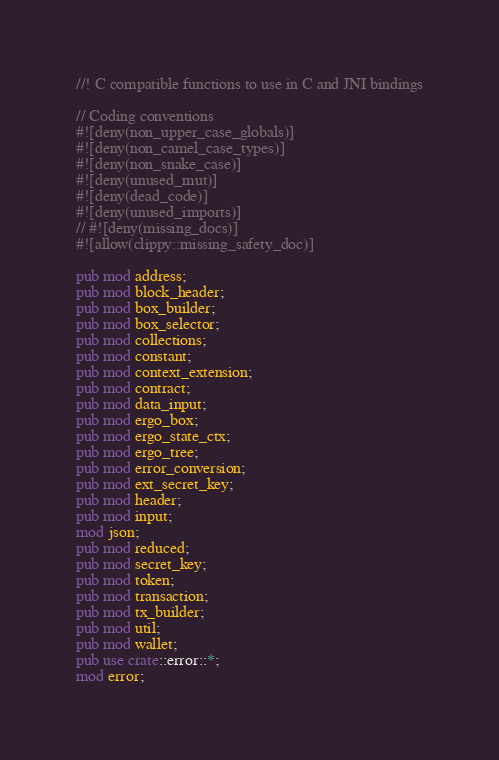Convert code to text. <code><loc_0><loc_0><loc_500><loc_500><_Rust_>//! C compatible functions to use in C and JNI bindings

// Coding conventions
#![deny(non_upper_case_globals)]
#![deny(non_camel_case_types)]
#![deny(non_snake_case)]
#![deny(unused_mut)]
#![deny(dead_code)]
#![deny(unused_imports)]
// #![deny(missing_docs)]
#![allow(clippy::missing_safety_doc)]

pub mod address;
pub mod block_header;
pub mod box_builder;
pub mod box_selector;
pub mod collections;
pub mod constant;
pub mod context_extension;
pub mod contract;
pub mod data_input;
pub mod ergo_box;
pub mod ergo_state_ctx;
pub mod ergo_tree;
pub mod error_conversion;
pub mod ext_secret_key;
pub mod header;
pub mod input;
mod json;
pub mod reduced;
pub mod secret_key;
pub mod token;
pub mod transaction;
pub mod tx_builder;
pub mod util;
pub mod wallet;
pub use crate::error::*;
mod error;
</code> 